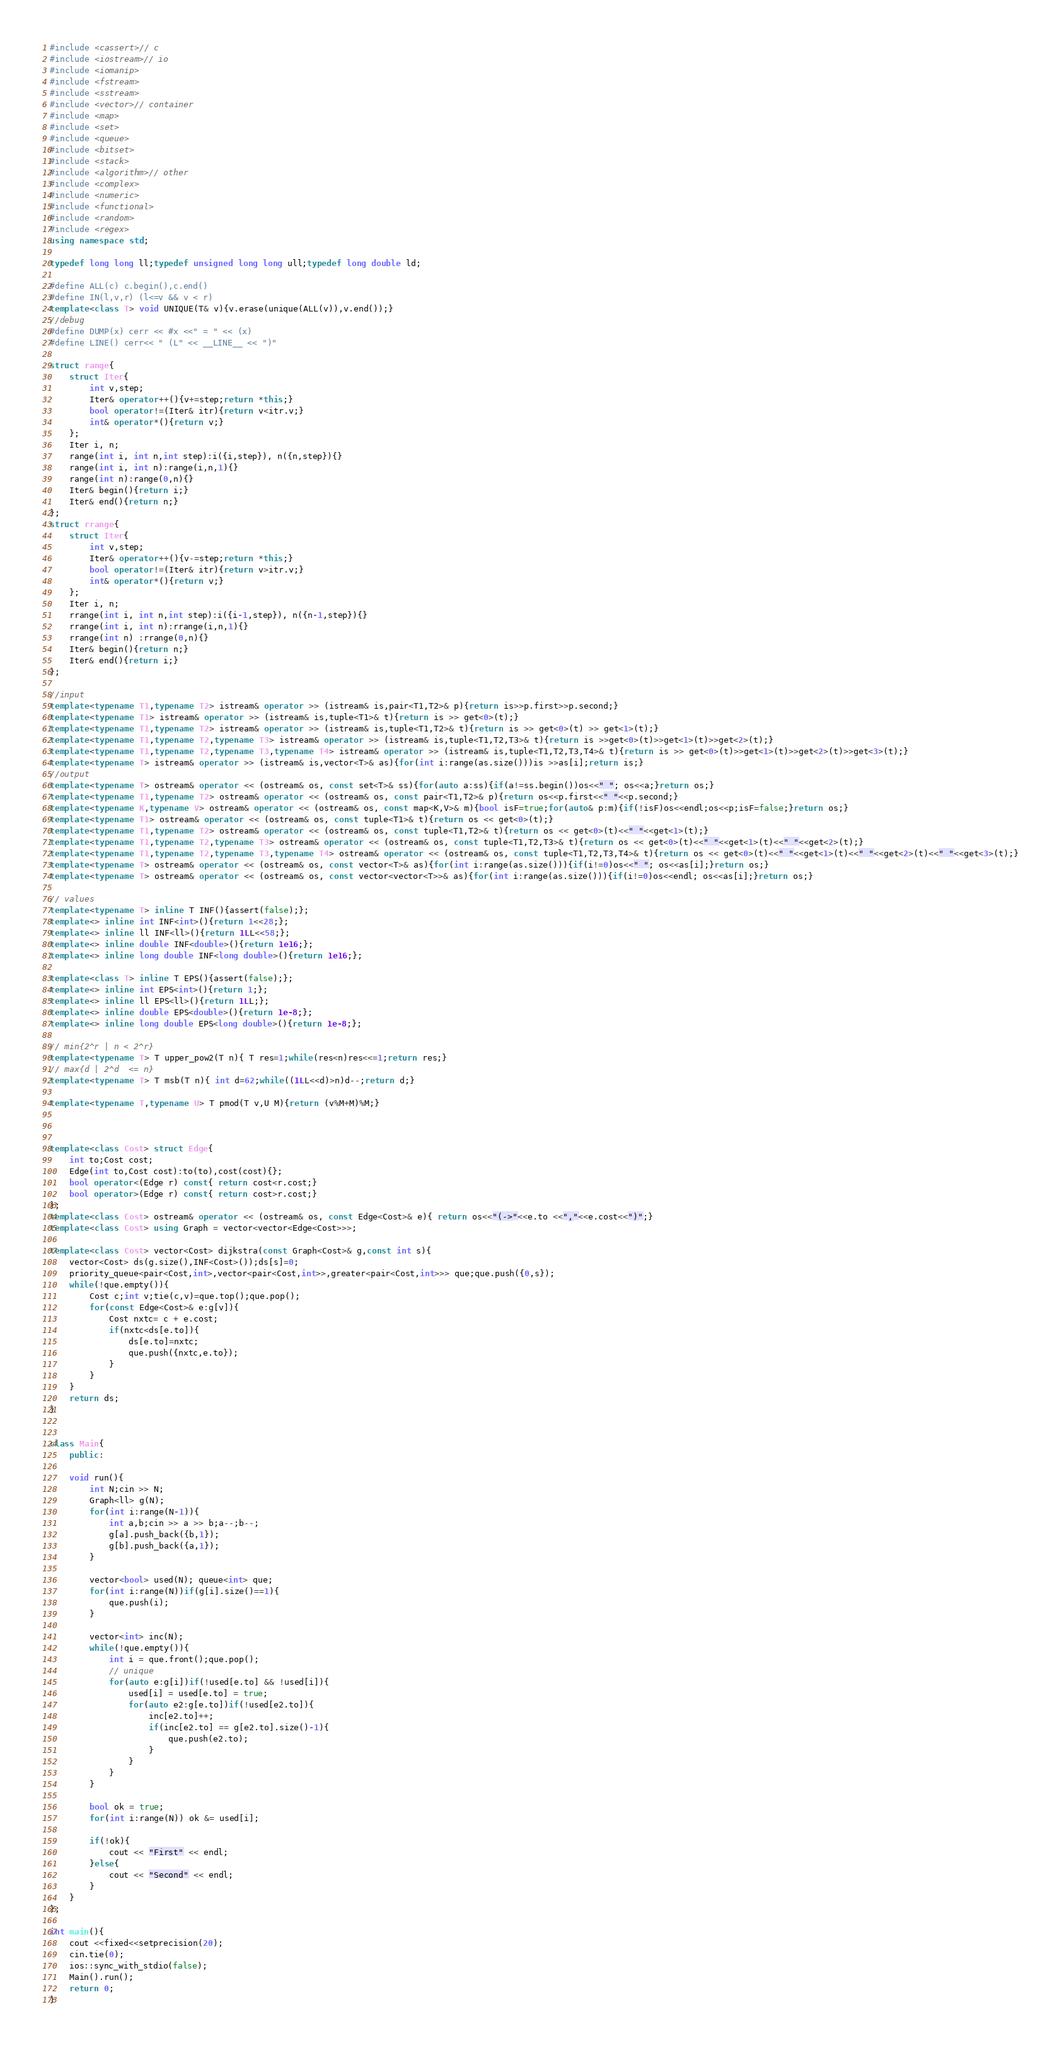Convert code to text. <code><loc_0><loc_0><loc_500><loc_500><_C++_>#include <cassert>// c
#include <iostream>// io
#include <iomanip>
#include <fstream>
#include <sstream>
#include <vector>// container
#include <map>
#include <set>
#include <queue>
#include <bitset>
#include <stack>
#include <algorithm>// other
#include <complex>
#include <numeric>
#include <functional>
#include <random>
#include <regex>
using namespace std;

typedef long long ll;typedef unsigned long long ull;typedef long double ld;

#define ALL(c) c.begin(),c.end()
#define IN(l,v,r) (l<=v && v < r)
template<class T> void UNIQUE(T& v){v.erase(unique(ALL(v)),v.end());}
//debug
#define DUMP(x) cerr << #x <<" = " << (x)
#define LINE() cerr<< " (L" << __LINE__ << ")"

struct range{
	struct Iter{
		int v,step;
		Iter& operator++(){v+=step;return *this;}
		bool operator!=(Iter& itr){return v<itr.v;}
		int& operator*(){return v;}
	};
	Iter i, n;
	range(int i, int n,int step):i({i,step}), n({n,step}){}
	range(int i, int n):range(i,n,1){}
	range(int n):range(0,n){}
	Iter& begin(){return i;}
	Iter& end(){return n;}
};
struct rrange{
	struct Iter{
		int v,step;
		Iter& operator++(){v-=step;return *this;}
		bool operator!=(Iter& itr){return v>itr.v;}
		int& operator*(){return v;}
	};
	Iter i, n;
	rrange(int i, int n,int step):i({i-1,step}), n({n-1,step}){}
	rrange(int i, int n):rrange(i,n,1){}
	rrange(int n) :rrange(0,n){}
	Iter& begin(){return n;}
	Iter& end(){return i;}
};

//input
template<typename T1,typename T2> istream& operator >> (istream& is,pair<T1,T2>& p){return is>>p.first>>p.second;}
template<typename T1> istream& operator >> (istream& is,tuple<T1>& t){return is >> get<0>(t);}
template<typename T1,typename T2> istream& operator >> (istream& is,tuple<T1,T2>& t){return is >> get<0>(t) >> get<1>(t);}
template<typename T1,typename T2,typename T3> istream& operator >> (istream& is,tuple<T1,T2,T3>& t){return is >>get<0>(t)>>get<1>(t)>>get<2>(t);}
template<typename T1,typename T2,typename T3,typename T4> istream& operator >> (istream& is,tuple<T1,T2,T3,T4>& t){return is >> get<0>(t)>>get<1>(t)>>get<2>(t)>>get<3>(t);}
template<typename T> istream& operator >> (istream& is,vector<T>& as){for(int i:range(as.size()))is >>as[i];return is;}
//output
template<typename T> ostream& operator << (ostream& os, const set<T>& ss){for(auto a:ss){if(a!=ss.begin())os<<" "; os<<a;}return os;}
template<typename T1,typename T2> ostream& operator << (ostream& os, const pair<T1,T2>& p){return os<<p.first<<" "<<p.second;}
template<typename K,typename V> ostream& operator << (ostream& os, const map<K,V>& m){bool isF=true;for(auto& p:m){if(!isF)os<<endl;os<<p;isF=false;}return os;}
template<typename T1> ostream& operator << (ostream& os, const tuple<T1>& t){return os << get<0>(t);}
template<typename T1,typename T2> ostream& operator << (ostream& os, const tuple<T1,T2>& t){return os << get<0>(t)<<" "<<get<1>(t);}
template<typename T1,typename T2,typename T3> ostream& operator << (ostream& os, const tuple<T1,T2,T3>& t){return os << get<0>(t)<<" "<<get<1>(t)<<" "<<get<2>(t);}
template<typename T1,typename T2,typename T3,typename T4> ostream& operator << (ostream& os, const tuple<T1,T2,T3,T4>& t){return os << get<0>(t)<<" "<<get<1>(t)<<" "<<get<2>(t)<<" "<<get<3>(t);}
template<typename T> ostream& operator << (ostream& os, const vector<T>& as){for(int i:range(as.size())){if(i!=0)os<<" "; os<<as[i];}return os;}
template<typename T> ostream& operator << (ostream& os, const vector<vector<T>>& as){for(int i:range(as.size())){if(i!=0)os<<endl; os<<as[i];}return os;}

// values
template<typename T> inline T INF(){assert(false);};
template<> inline int INF<int>(){return 1<<28;};
template<> inline ll INF<ll>(){return 1LL<<58;};
template<> inline double INF<double>(){return 1e16;};
template<> inline long double INF<long double>(){return 1e16;};

template<class T> inline T EPS(){assert(false);};
template<> inline int EPS<int>(){return 1;};
template<> inline ll EPS<ll>(){return 1LL;};
template<> inline double EPS<double>(){return 1e-8;};
template<> inline long double EPS<long double>(){return 1e-8;};

// min{2^r | n < 2^r}
template<typename T> T upper_pow2(T n){ T res=1;while(res<n)res<<=1;return res;}
// max{d | 2^d  <= n}
template<typename T> T msb(T n){ int d=62;while((1LL<<d)>n)d--;return d;}

template<typename T,typename U> T pmod(T v,U M){return (v%M+M)%M;}



template<class Cost> struct Edge{
    int to;Cost cost;
    Edge(int to,Cost cost):to(to),cost(cost){};
    bool operator<(Edge r) const{ return cost<r.cost;}
    bool operator>(Edge r) const{ return cost>r.cost;}
};
template<class Cost> ostream& operator << (ostream& os, const Edge<Cost>& e){ return os<<"(->"<<e.to <<","<<e.cost<<")";}
template<class Cost> using Graph = vector<vector<Edge<Cost>>>;

template<class Cost> vector<Cost> dijkstra(const Graph<Cost>& g,const int s){
    vector<Cost> ds(g.size(),INF<Cost>());ds[s]=0;
    priority_queue<pair<Cost,int>,vector<pair<Cost,int>>,greater<pair<Cost,int>>> que;que.push({0,s});
    while(!que.empty()){
        Cost c;int v;tie(c,v)=que.top();que.pop();
        for(const Edge<Cost>& e:g[v]){
            Cost nxtc= c + e.cost;
            if(nxtc<ds[e.to]){
                ds[e.to]=nxtc;
                que.push({nxtc,e.to});
            }
        }
    }
    return ds;
}


class Main{
	public:

	void run(){
		int N;cin >> N;
		Graph<ll> g(N);
		for(int i:range(N-1)){
			int a,b;cin >> a >> b;a--;b--;
			g[a].push_back({b,1});
			g[b].push_back({a,1});
		}

		vector<bool> used(N); queue<int> que;
		for(int i:range(N))if(g[i].size()==1){
			que.push(i);
		}

		vector<int> inc(N);
		while(!que.empty()){
			int i = que.front();que.pop();
			// unique
			for(auto e:g[i])if(!used[e.to] && !used[i]){
				used[i] = used[e.to] = true;
				for(auto e2:g[e.to])if(!used[e2.to]){
					inc[e2.to]++;
					if(inc[e2.to] == g[e2.to].size()-1){
						que.push(e2.to);
					}
				}
			}
		}
	
		bool ok = true;
		for(int i:range(N)) ok &= used[i];

		if(!ok){
			cout << "First" << endl;
		}else{
			cout << "Second" << endl;
		}
	}
};

int main(){
	cout <<fixed<<setprecision(20);
	cin.tie(0);
	ios::sync_with_stdio(false);
	Main().run();
	return 0;
}
</code> 